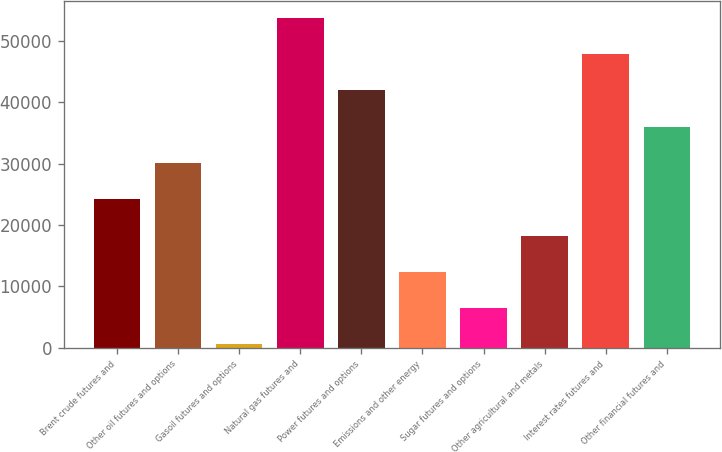<chart> <loc_0><loc_0><loc_500><loc_500><bar_chart><fcel>Brent crude futures and<fcel>Other oil futures and options<fcel>Gasoil futures and options<fcel>Natural gas futures and<fcel>Power futures and options<fcel>Emissions and other energy<fcel>Sugar futures and options<fcel>Other agricultural and metals<fcel>Interest rates futures and<fcel>Other financial futures and<nl><fcel>24200<fcel>30118.5<fcel>526<fcel>53792.5<fcel>41955.5<fcel>12363<fcel>6444.5<fcel>18281.5<fcel>47874<fcel>36037<nl></chart> 